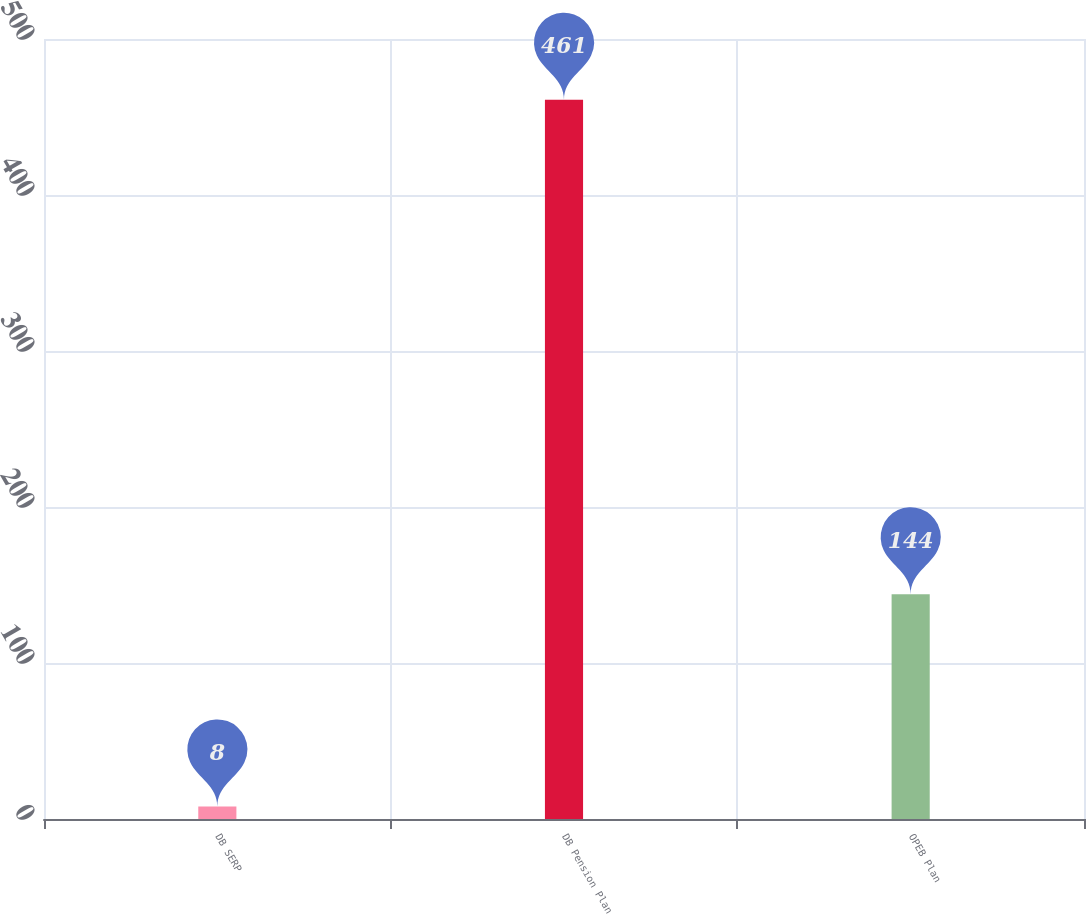<chart> <loc_0><loc_0><loc_500><loc_500><bar_chart><fcel>DB SERP<fcel>DB Pension Plan<fcel>OPEB Plan<nl><fcel>8<fcel>461<fcel>144<nl></chart> 